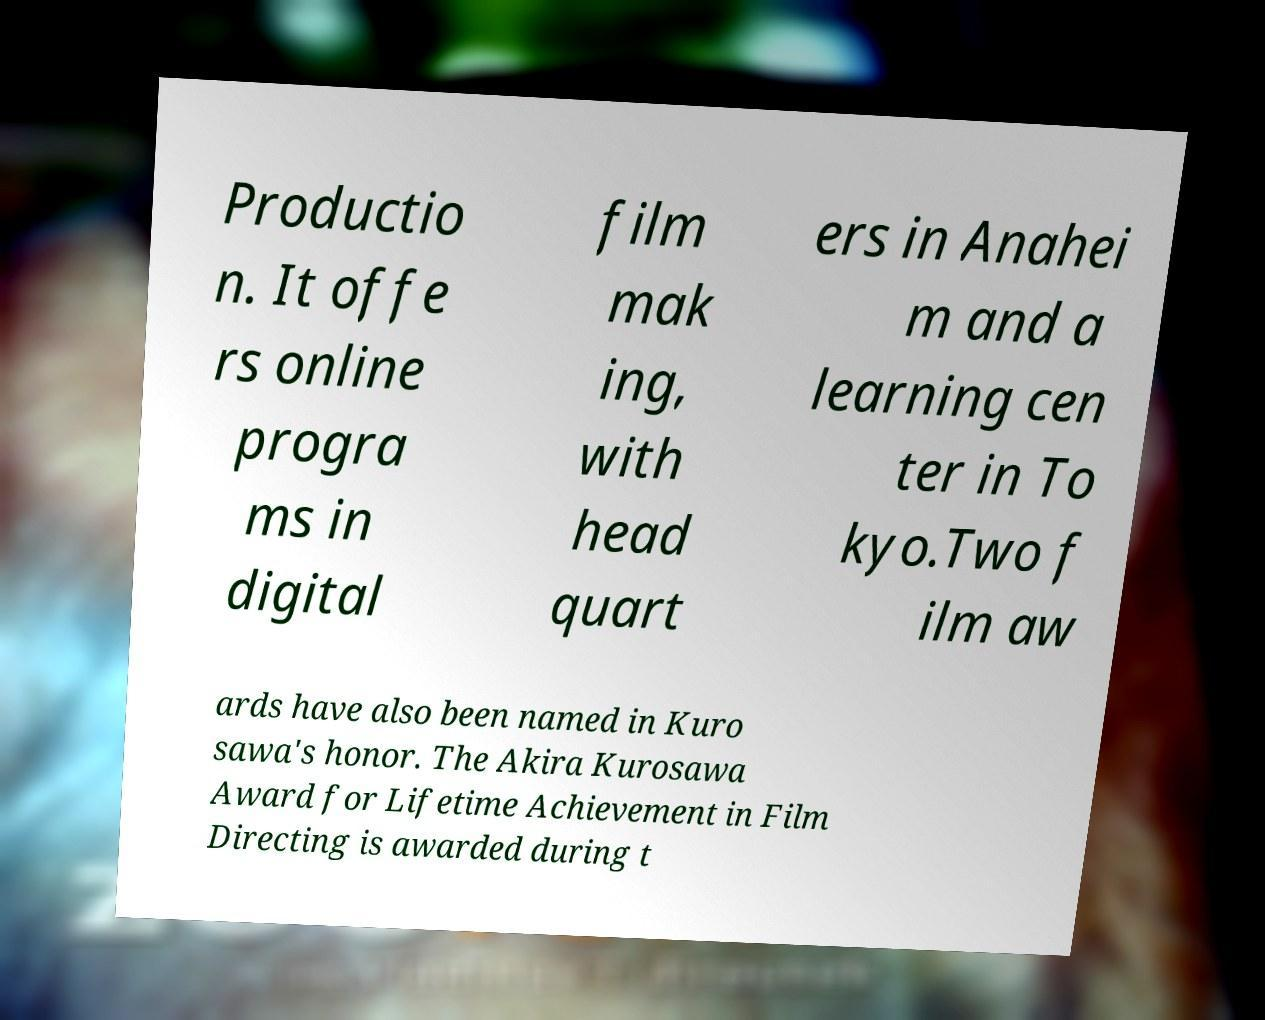For documentation purposes, I need the text within this image transcribed. Could you provide that? Productio n. It offe rs online progra ms in digital film mak ing, with head quart ers in Anahei m and a learning cen ter in To kyo.Two f ilm aw ards have also been named in Kuro sawa's honor. The Akira Kurosawa Award for Lifetime Achievement in Film Directing is awarded during t 